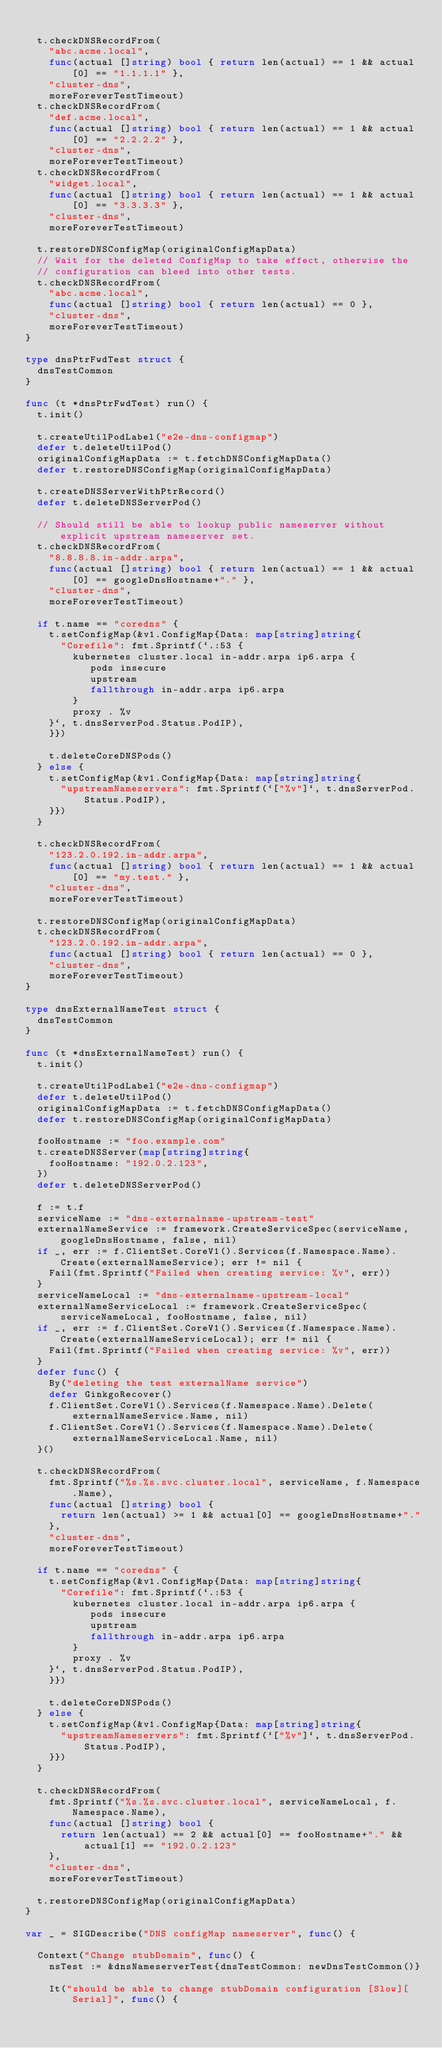<code> <loc_0><loc_0><loc_500><loc_500><_Go_>
	t.checkDNSRecordFrom(
		"abc.acme.local",
		func(actual []string) bool { return len(actual) == 1 && actual[0] == "1.1.1.1" },
		"cluster-dns",
		moreForeverTestTimeout)
	t.checkDNSRecordFrom(
		"def.acme.local",
		func(actual []string) bool { return len(actual) == 1 && actual[0] == "2.2.2.2" },
		"cluster-dns",
		moreForeverTestTimeout)
	t.checkDNSRecordFrom(
		"widget.local",
		func(actual []string) bool { return len(actual) == 1 && actual[0] == "3.3.3.3" },
		"cluster-dns",
		moreForeverTestTimeout)

	t.restoreDNSConfigMap(originalConfigMapData)
	// Wait for the deleted ConfigMap to take effect, otherwise the
	// configuration can bleed into other tests.
	t.checkDNSRecordFrom(
		"abc.acme.local",
		func(actual []string) bool { return len(actual) == 0 },
		"cluster-dns",
		moreForeverTestTimeout)
}

type dnsPtrFwdTest struct {
	dnsTestCommon
}

func (t *dnsPtrFwdTest) run() {
	t.init()

	t.createUtilPodLabel("e2e-dns-configmap")
	defer t.deleteUtilPod()
	originalConfigMapData := t.fetchDNSConfigMapData()
	defer t.restoreDNSConfigMap(originalConfigMapData)

	t.createDNSServerWithPtrRecord()
	defer t.deleteDNSServerPod()

	// Should still be able to lookup public nameserver without explicit upstream nameserver set.
	t.checkDNSRecordFrom(
		"8.8.8.8.in-addr.arpa",
		func(actual []string) bool { return len(actual) == 1 && actual[0] == googleDnsHostname+"." },
		"cluster-dns",
		moreForeverTestTimeout)

	if t.name == "coredns" {
		t.setConfigMap(&v1.ConfigMap{Data: map[string]string{
			"Corefile": fmt.Sprintf(`.:53 {
        kubernetes cluster.local in-addr.arpa ip6.arpa {
           pods insecure
           upstream
           fallthrough in-addr.arpa ip6.arpa
        }
        proxy . %v
    }`, t.dnsServerPod.Status.PodIP),
		}})

		t.deleteCoreDNSPods()
	} else {
		t.setConfigMap(&v1.ConfigMap{Data: map[string]string{
			"upstreamNameservers": fmt.Sprintf(`["%v"]`, t.dnsServerPod.Status.PodIP),
		}})
	}

	t.checkDNSRecordFrom(
		"123.2.0.192.in-addr.arpa",
		func(actual []string) bool { return len(actual) == 1 && actual[0] == "my.test." },
		"cluster-dns",
		moreForeverTestTimeout)

	t.restoreDNSConfigMap(originalConfigMapData)
	t.checkDNSRecordFrom(
		"123.2.0.192.in-addr.arpa",
		func(actual []string) bool { return len(actual) == 0 },
		"cluster-dns",
		moreForeverTestTimeout)
}

type dnsExternalNameTest struct {
	dnsTestCommon
}

func (t *dnsExternalNameTest) run() {
	t.init()

	t.createUtilPodLabel("e2e-dns-configmap")
	defer t.deleteUtilPod()
	originalConfigMapData := t.fetchDNSConfigMapData()
	defer t.restoreDNSConfigMap(originalConfigMapData)

	fooHostname := "foo.example.com"
	t.createDNSServer(map[string]string{
		fooHostname: "192.0.2.123",
	})
	defer t.deleteDNSServerPod()

	f := t.f
	serviceName := "dns-externalname-upstream-test"
	externalNameService := framework.CreateServiceSpec(serviceName, googleDnsHostname, false, nil)
	if _, err := f.ClientSet.CoreV1().Services(f.Namespace.Name).Create(externalNameService); err != nil {
		Fail(fmt.Sprintf("Failed when creating service: %v", err))
	}
	serviceNameLocal := "dns-externalname-upstream-local"
	externalNameServiceLocal := framework.CreateServiceSpec(serviceNameLocal, fooHostname, false, nil)
	if _, err := f.ClientSet.CoreV1().Services(f.Namespace.Name).Create(externalNameServiceLocal); err != nil {
		Fail(fmt.Sprintf("Failed when creating service: %v", err))
	}
	defer func() {
		By("deleting the test externalName service")
		defer GinkgoRecover()
		f.ClientSet.CoreV1().Services(f.Namespace.Name).Delete(externalNameService.Name, nil)
		f.ClientSet.CoreV1().Services(f.Namespace.Name).Delete(externalNameServiceLocal.Name, nil)
	}()

	t.checkDNSRecordFrom(
		fmt.Sprintf("%s.%s.svc.cluster.local", serviceName, f.Namespace.Name),
		func(actual []string) bool {
			return len(actual) >= 1 && actual[0] == googleDnsHostname+"."
		},
		"cluster-dns",
		moreForeverTestTimeout)

	if t.name == "coredns" {
		t.setConfigMap(&v1.ConfigMap{Data: map[string]string{
			"Corefile": fmt.Sprintf(`.:53 {
        kubernetes cluster.local in-addr.arpa ip6.arpa {
           pods insecure
           upstream
           fallthrough in-addr.arpa ip6.arpa
        }
        proxy . %v
    }`, t.dnsServerPod.Status.PodIP),
		}})

		t.deleteCoreDNSPods()
	} else {
		t.setConfigMap(&v1.ConfigMap{Data: map[string]string{
			"upstreamNameservers": fmt.Sprintf(`["%v"]`, t.dnsServerPod.Status.PodIP),
		}})
	}

	t.checkDNSRecordFrom(
		fmt.Sprintf("%s.%s.svc.cluster.local", serviceNameLocal, f.Namespace.Name),
		func(actual []string) bool {
			return len(actual) == 2 && actual[0] == fooHostname+"." && actual[1] == "192.0.2.123"
		},
		"cluster-dns",
		moreForeverTestTimeout)

	t.restoreDNSConfigMap(originalConfigMapData)
}

var _ = SIGDescribe("DNS configMap nameserver", func() {

	Context("Change stubDomain", func() {
		nsTest := &dnsNameserverTest{dnsTestCommon: newDnsTestCommon()}

		It("should be able to change stubDomain configuration [Slow][Serial]", func() {</code> 